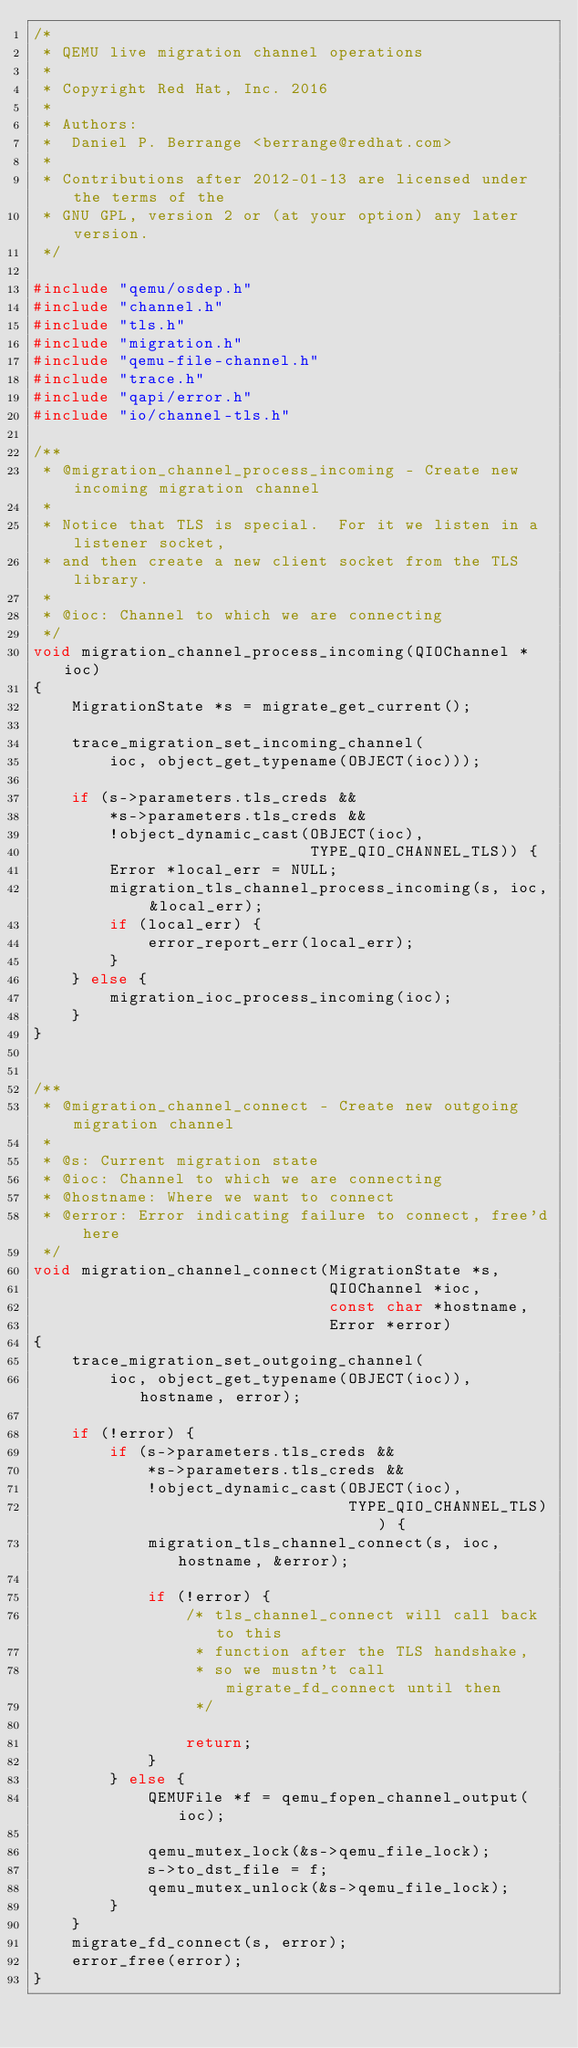Convert code to text. <code><loc_0><loc_0><loc_500><loc_500><_C_>/*
 * QEMU live migration channel operations
 *
 * Copyright Red Hat, Inc. 2016
 *
 * Authors:
 *  Daniel P. Berrange <berrange@redhat.com>
 *
 * Contributions after 2012-01-13 are licensed under the terms of the
 * GNU GPL, version 2 or (at your option) any later version.
 */

#include "qemu/osdep.h"
#include "channel.h"
#include "tls.h"
#include "migration.h"
#include "qemu-file-channel.h"
#include "trace.h"
#include "qapi/error.h"
#include "io/channel-tls.h"

/**
 * @migration_channel_process_incoming - Create new incoming migration channel
 *
 * Notice that TLS is special.  For it we listen in a listener socket,
 * and then create a new client socket from the TLS library.
 *
 * @ioc: Channel to which we are connecting
 */
void migration_channel_process_incoming(QIOChannel *ioc)
{
    MigrationState *s = migrate_get_current();

    trace_migration_set_incoming_channel(
        ioc, object_get_typename(OBJECT(ioc)));

    if (s->parameters.tls_creds &&
        *s->parameters.tls_creds &&
        !object_dynamic_cast(OBJECT(ioc),
                             TYPE_QIO_CHANNEL_TLS)) {
        Error *local_err = NULL;
        migration_tls_channel_process_incoming(s, ioc, &local_err);
        if (local_err) {
            error_report_err(local_err);
        }
    } else {
        migration_ioc_process_incoming(ioc);
    }
}


/**
 * @migration_channel_connect - Create new outgoing migration channel
 *
 * @s: Current migration state
 * @ioc: Channel to which we are connecting
 * @hostname: Where we want to connect
 * @error: Error indicating failure to connect, free'd here
 */
void migration_channel_connect(MigrationState *s,
                               QIOChannel *ioc,
                               const char *hostname,
                               Error *error)
{
    trace_migration_set_outgoing_channel(
        ioc, object_get_typename(OBJECT(ioc)), hostname, error);

    if (!error) {
        if (s->parameters.tls_creds &&
            *s->parameters.tls_creds &&
            !object_dynamic_cast(OBJECT(ioc),
                                 TYPE_QIO_CHANNEL_TLS)) {
            migration_tls_channel_connect(s, ioc, hostname, &error);

            if (!error) {
                /* tls_channel_connect will call back to this
                 * function after the TLS handshake,
                 * so we mustn't call migrate_fd_connect until then
                 */

                return;
            }
        } else {
            QEMUFile *f = qemu_fopen_channel_output(ioc);

            qemu_mutex_lock(&s->qemu_file_lock);
            s->to_dst_file = f;
            qemu_mutex_unlock(&s->qemu_file_lock);
        }
    }
    migrate_fd_connect(s, error);
    error_free(error);
}
</code> 